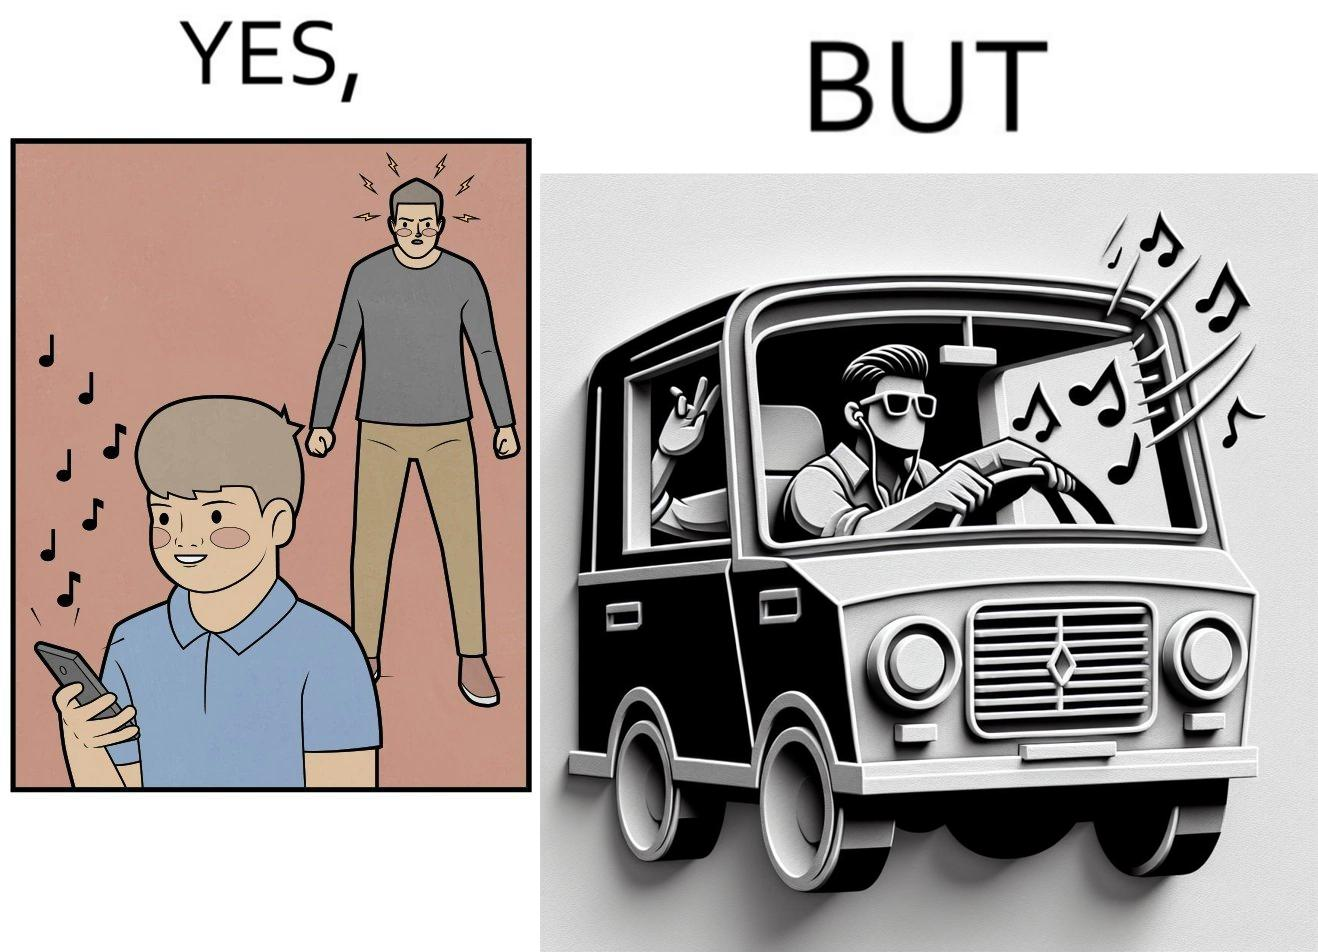Is this image satirical or non-satirical? Yes, this image is satirical. 